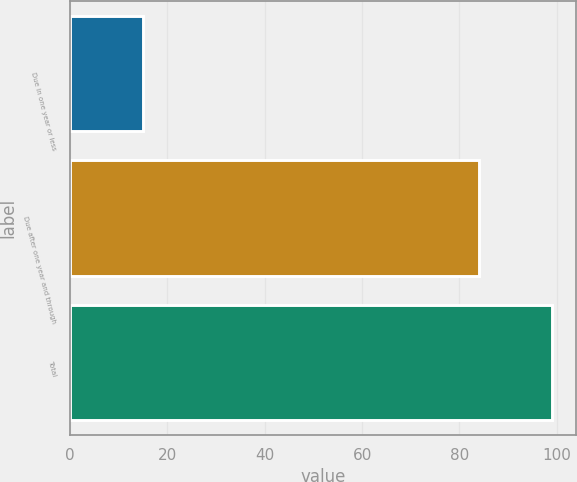<chart> <loc_0><loc_0><loc_500><loc_500><bar_chart><fcel>Due in one year or less<fcel>Due after one year and through<fcel>Total<nl><fcel>15<fcel>84<fcel>99<nl></chart> 